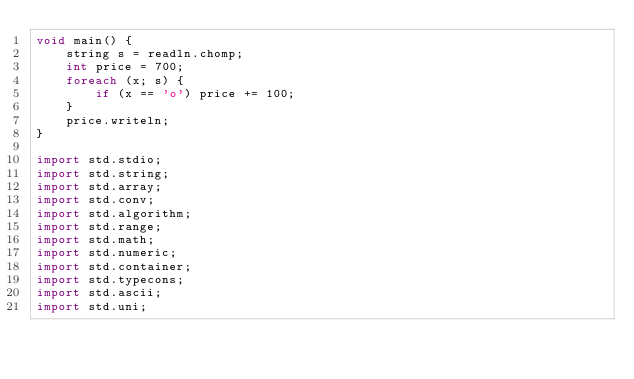Convert code to text. <code><loc_0><loc_0><loc_500><loc_500><_D_>void main() {
    string s = readln.chomp;
    int price = 700;
    foreach (x; s) {
        if (x == 'o') price += 100;
    }
    price.writeln;
}

import std.stdio;
import std.string;
import std.array;
import std.conv;
import std.algorithm;
import std.range;
import std.math;
import std.numeric;
import std.container;
import std.typecons;
import std.ascii;
import std.uni;</code> 